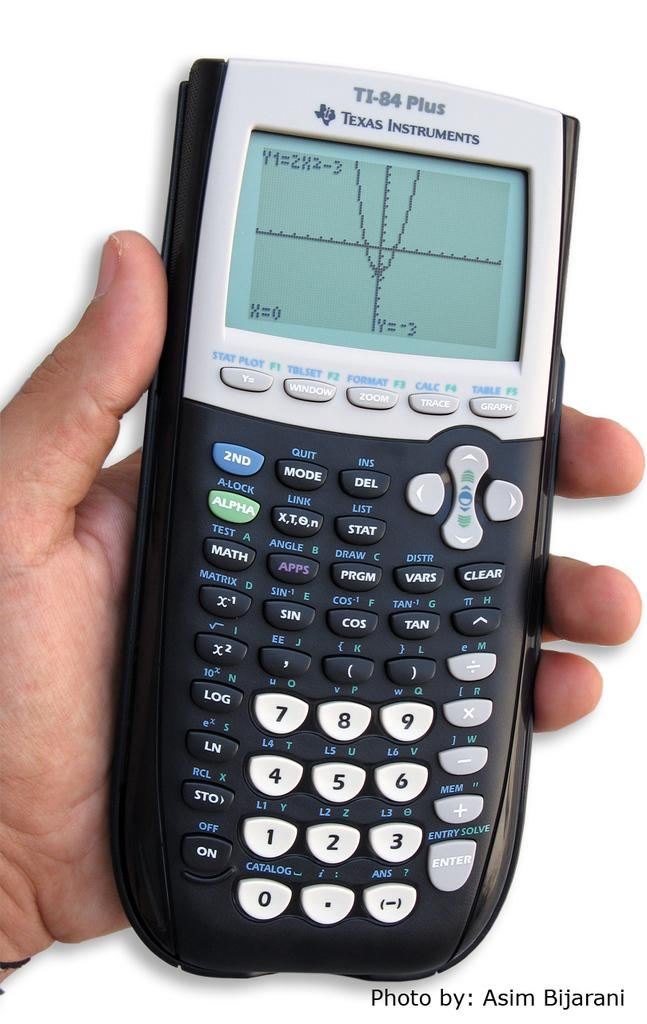<image>
Describe the image concisely. a t1-84 plus texas instruments grapic math caculator 